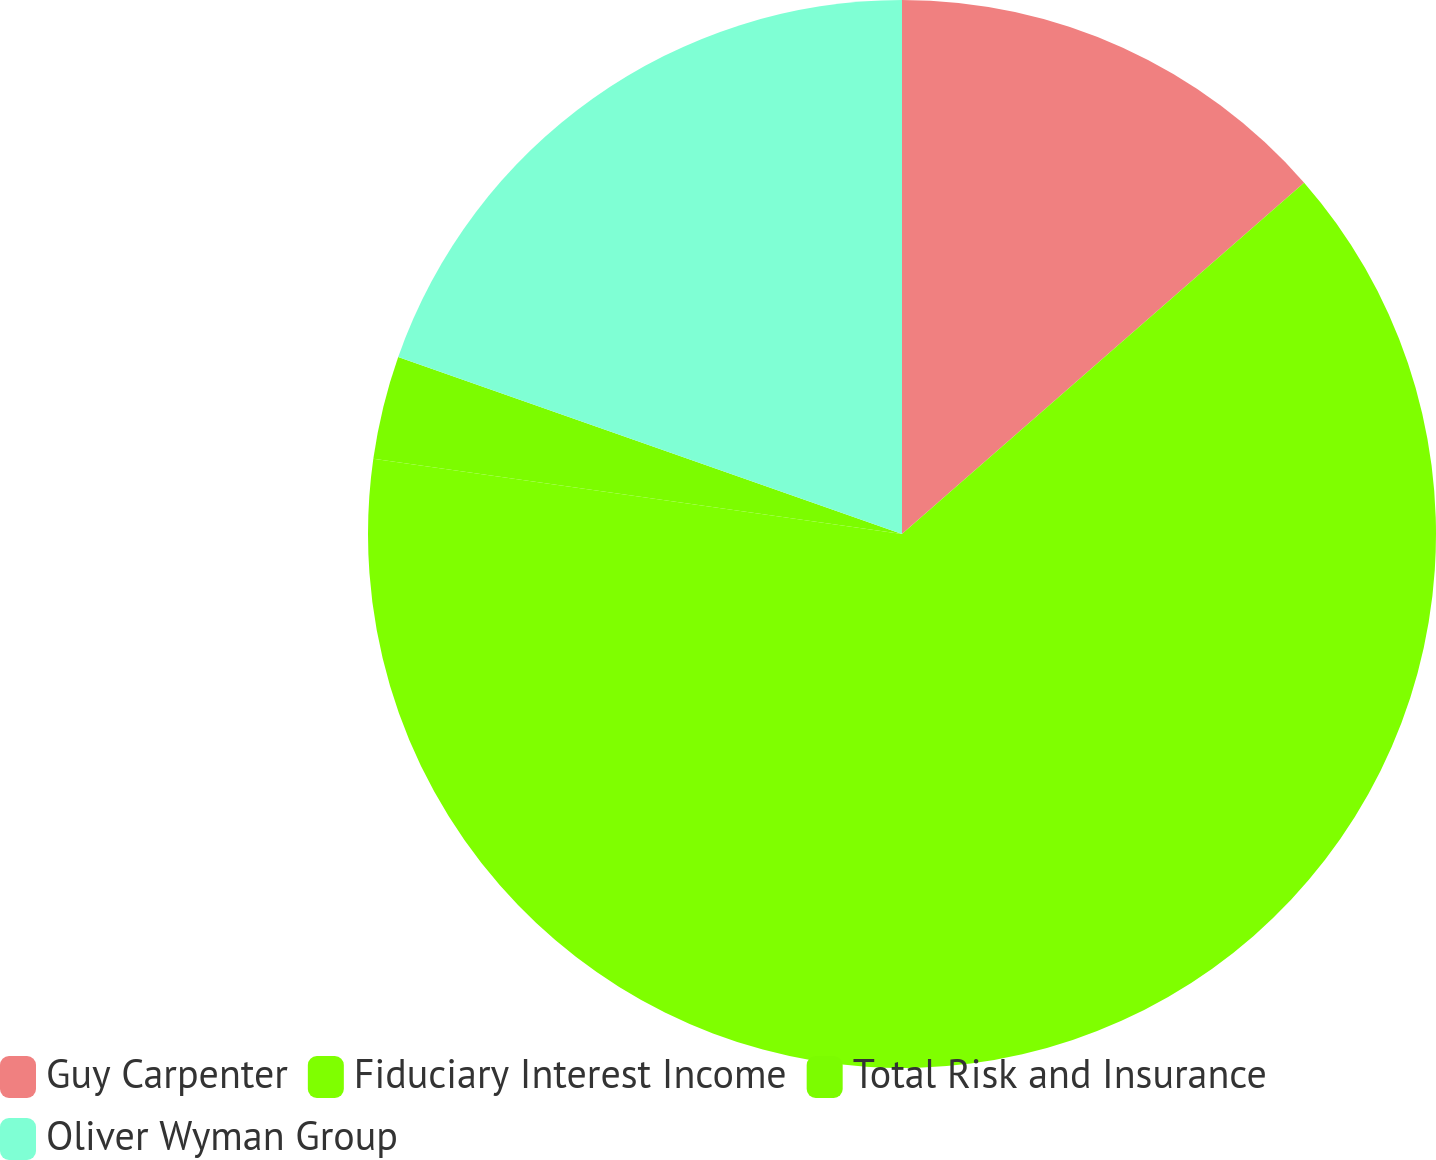Convert chart to OTSL. <chart><loc_0><loc_0><loc_500><loc_500><pie_chart><fcel>Guy Carpenter<fcel>Fiduciary Interest Income<fcel>Total Risk and Insurance<fcel>Oliver Wyman Group<nl><fcel>13.57%<fcel>63.67%<fcel>3.13%<fcel>19.62%<nl></chart> 